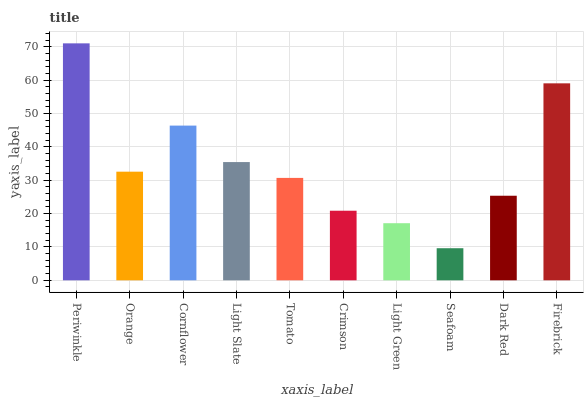Is Seafoam the minimum?
Answer yes or no. Yes. Is Periwinkle the maximum?
Answer yes or no. Yes. Is Orange the minimum?
Answer yes or no. No. Is Orange the maximum?
Answer yes or no. No. Is Periwinkle greater than Orange?
Answer yes or no. Yes. Is Orange less than Periwinkle?
Answer yes or no. Yes. Is Orange greater than Periwinkle?
Answer yes or no. No. Is Periwinkle less than Orange?
Answer yes or no. No. Is Orange the high median?
Answer yes or no. Yes. Is Tomato the low median?
Answer yes or no. Yes. Is Light Slate the high median?
Answer yes or no. No. Is Periwinkle the low median?
Answer yes or no. No. 